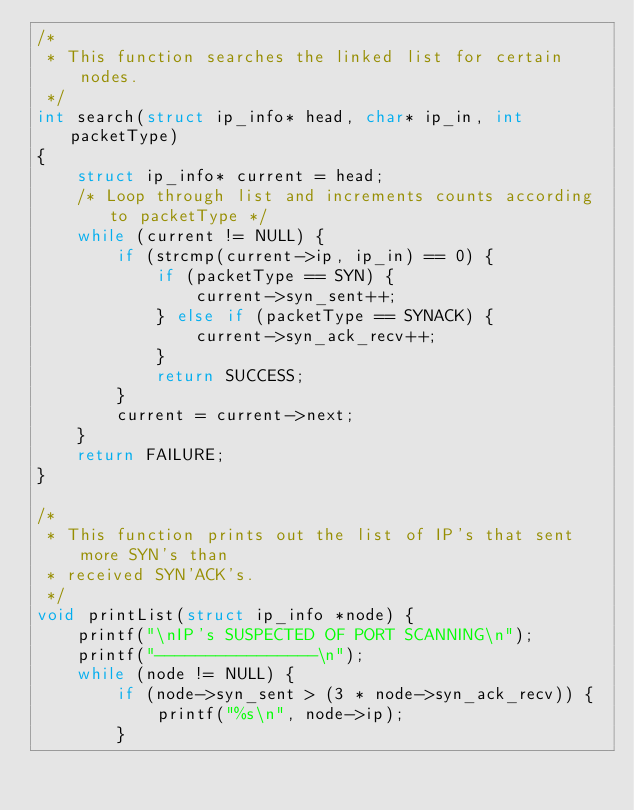Convert code to text. <code><loc_0><loc_0><loc_500><loc_500><_C_>/*
 * This function searches the linked list for certain nodes.
 */
int search(struct ip_info* head, char* ip_in, int packetType) 
{
    struct ip_info* current = head;
    /* Loop through list and increments counts according to packetType */
    while (current != NULL) {
        if (strcmp(current->ip, ip_in) == 0) {
            if (packetType == SYN) {
                current->syn_sent++;
            } else if (packetType == SYNACK) {
                current->syn_ack_recv++;
            }
            return SUCCESS;
        }
        current = current->next; 
    }
    return FAILURE; 
}

/*
 * This function prints out the list of IP's that sent more SYN's than
 * received SYN'ACK's.
 */
void printList(struct ip_info *node) {
    printf("\nIP's SUSPECTED OF PORT SCANNING\n");
    printf("----------------\n");
    while (node != NULL) {
        if (node->syn_sent > (3 * node->syn_ack_recv)) {
            printf("%s\n", node->ip);
        }</code> 